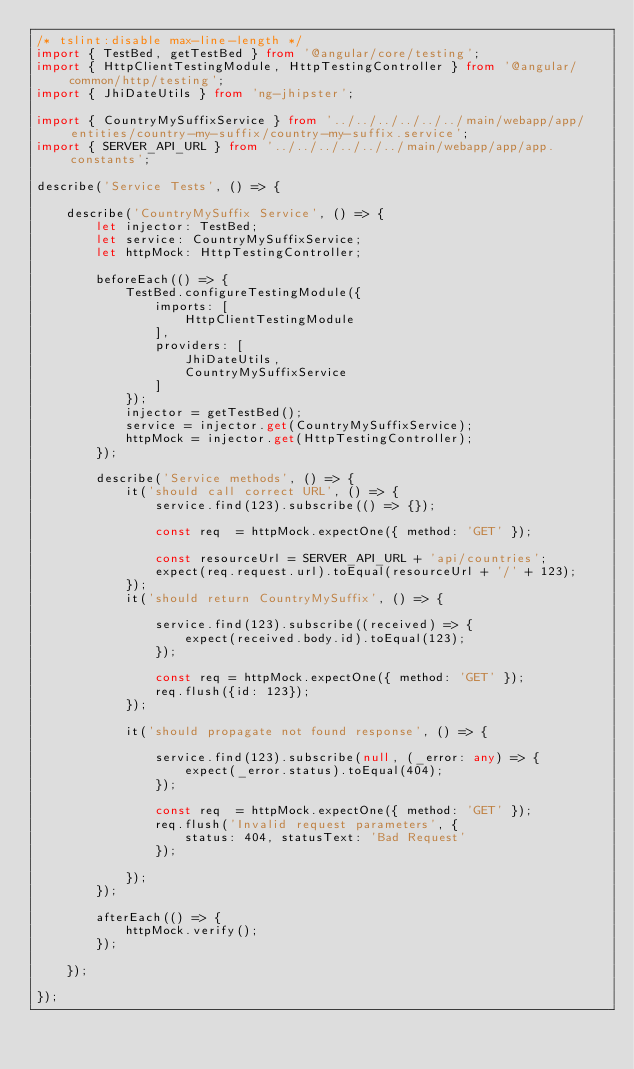Convert code to text. <code><loc_0><loc_0><loc_500><loc_500><_TypeScript_>/* tslint:disable max-line-length */
import { TestBed, getTestBed } from '@angular/core/testing';
import { HttpClientTestingModule, HttpTestingController } from '@angular/common/http/testing';
import { JhiDateUtils } from 'ng-jhipster';

import { CountryMySuffixService } from '../../../../../../main/webapp/app/entities/country-my-suffix/country-my-suffix.service';
import { SERVER_API_URL } from '../../../../../../main/webapp/app/app.constants';

describe('Service Tests', () => {

    describe('CountryMySuffix Service', () => {
        let injector: TestBed;
        let service: CountryMySuffixService;
        let httpMock: HttpTestingController;

        beforeEach(() => {
            TestBed.configureTestingModule({
                imports: [
                    HttpClientTestingModule
                ],
                providers: [
                    JhiDateUtils,
                    CountryMySuffixService
                ]
            });
            injector = getTestBed();
            service = injector.get(CountryMySuffixService);
            httpMock = injector.get(HttpTestingController);
        });

        describe('Service methods', () => {
            it('should call correct URL', () => {
                service.find(123).subscribe(() => {});

                const req  = httpMock.expectOne({ method: 'GET' });

                const resourceUrl = SERVER_API_URL + 'api/countries';
                expect(req.request.url).toEqual(resourceUrl + '/' + 123);
            });
            it('should return CountryMySuffix', () => {

                service.find(123).subscribe((received) => {
                    expect(received.body.id).toEqual(123);
                });

                const req = httpMock.expectOne({ method: 'GET' });
                req.flush({id: 123});
            });

            it('should propagate not found response', () => {

                service.find(123).subscribe(null, (_error: any) => {
                    expect(_error.status).toEqual(404);
                });

                const req  = httpMock.expectOne({ method: 'GET' });
                req.flush('Invalid request parameters', {
                    status: 404, statusText: 'Bad Request'
                });

            });
        });

        afterEach(() => {
            httpMock.verify();
        });

    });

});
</code> 